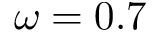<formula> <loc_0><loc_0><loc_500><loc_500>\omega = 0 . 7</formula> 